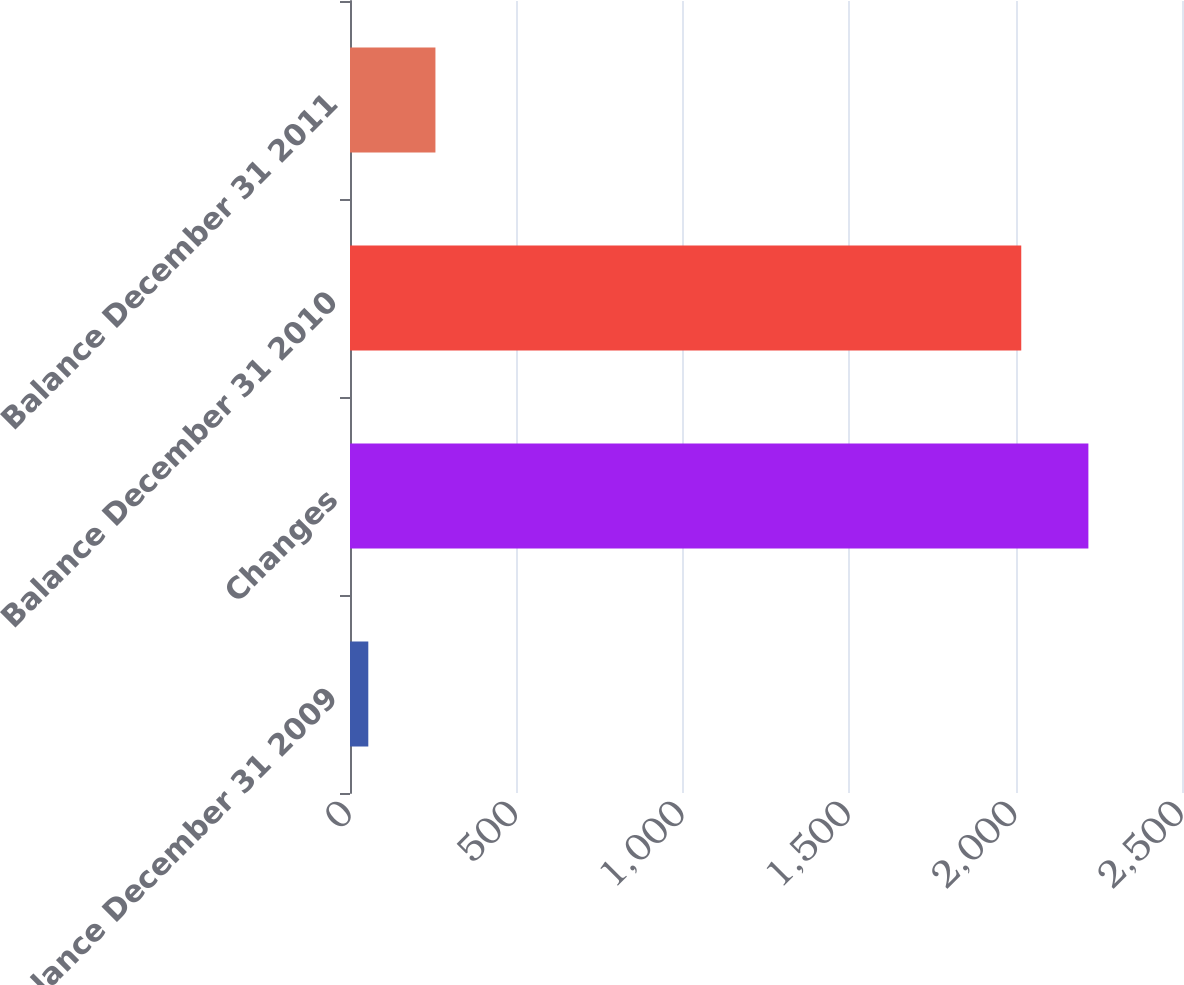Convert chart to OTSL. <chart><loc_0><loc_0><loc_500><loc_500><bar_chart><fcel>Balance December 31 2009<fcel>Changes<fcel>Balance December 31 2010<fcel>Balance December 31 2011<nl><fcel>55<fcel>2218.7<fcel>2017<fcel>256.7<nl></chart> 